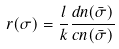<formula> <loc_0><loc_0><loc_500><loc_500>r ( \sigma ) = \frac { l } { k } \frac { d n ( \bar { \sigma } ) } { c n ( \bar { \sigma } ) }</formula> 